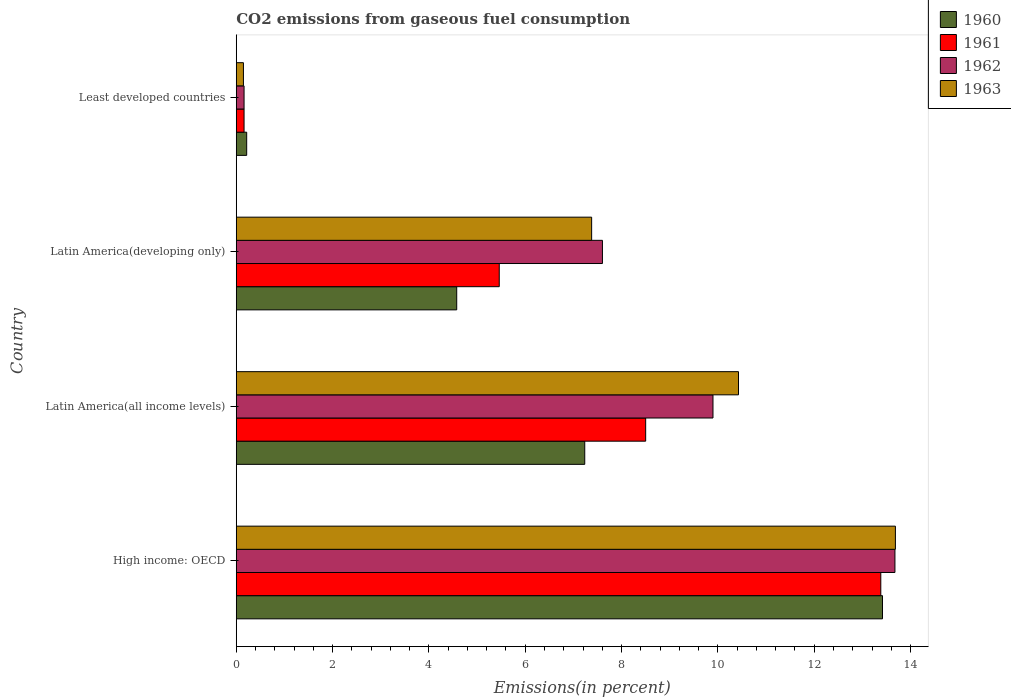Are the number of bars on each tick of the Y-axis equal?
Make the answer very short. Yes. How many bars are there on the 4th tick from the top?
Offer a very short reply. 4. What is the label of the 2nd group of bars from the top?
Your answer should be compact. Latin America(developing only). In how many cases, is the number of bars for a given country not equal to the number of legend labels?
Provide a succinct answer. 0. What is the total CO2 emitted in 1963 in Latin America(developing only)?
Your answer should be very brief. 7.38. Across all countries, what is the maximum total CO2 emitted in 1961?
Your response must be concise. 13.38. Across all countries, what is the minimum total CO2 emitted in 1961?
Keep it short and to the point. 0.16. In which country was the total CO2 emitted in 1960 maximum?
Offer a very short reply. High income: OECD. In which country was the total CO2 emitted in 1962 minimum?
Keep it short and to the point. Least developed countries. What is the total total CO2 emitted in 1961 in the graph?
Your response must be concise. 27.51. What is the difference between the total CO2 emitted in 1962 in High income: OECD and that in Least developed countries?
Ensure brevity in your answer.  13.51. What is the difference between the total CO2 emitted in 1963 in Latin America(developing only) and the total CO2 emitted in 1960 in Least developed countries?
Your answer should be compact. 7.16. What is the average total CO2 emitted in 1963 per country?
Give a very brief answer. 7.91. What is the difference between the total CO2 emitted in 1960 and total CO2 emitted in 1962 in High income: OECD?
Your answer should be very brief. -0.26. What is the ratio of the total CO2 emitted in 1961 in Latin America(all income levels) to that in Least developed countries?
Provide a short and direct response. 52.47. Is the total CO2 emitted in 1961 in High income: OECD less than that in Latin America(all income levels)?
Offer a very short reply. No. Is the difference between the total CO2 emitted in 1960 in Latin America(all income levels) and Latin America(developing only) greater than the difference between the total CO2 emitted in 1962 in Latin America(all income levels) and Latin America(developing only)?
Give a very brief answer. Yes. What is the difference between the highest and the second highest total CO2 emitted in 1962?
Provide a short and direct response. 3.78. What is the difference between the highest and the lowest total CO2 emitted in 1961?
Keep it short and to the point. 13.22. Is it the case that in every country, the sum of the total CO2 emitted in 1962 and total CO2 emitted in 1960 is greater than the total CO2 emitted in 1961?
Your answer should be very brief. Yes. How many countries are there in the graph?
Give a very brief answer. 4. What is the difference between two consecutive major ticks on the X-axis?
Your answer should be compact. 2. Does the graph contain any zero values?
Ensure brevity in your answer.  No. Does the graph contain grids?
Your response must be concise. No. What is the title of the graph?
Make the answer very short. CO2 emissions from gaseous fuel consumption. What is the label or title of the X-axis?
Keep it short and to the point. Emissions(in percent). What is the Emissions(in percent) of 1960 in High income: OECD?
Offer a very short reply. 13.42. What is the Emissions(in percent) in 1961 in High income: OECD?
Offer a terse response. 13.38. What is the Emissions(in percent) in 1962 in High income: OECD?
Your answer should be very brief. 13.68. What is the Emissions(in percent) in 1963 in High income: OECD?
Ensure brevity in your answer.  13.69. What is the Emissions(in percent) of 1960 in Latin America(all income levels)?
Offer a terse response. 7.24. What is the Emissions(in percent) of 1961 in Latin America(all income levels)?
Your answer should be compact. 8.5. What is the Emissions(in percent) in 1962 in Latin America(all income levels)?
Your answer should be compact. 9.9. What is the Emissions(in percent) of 1963 in Latin America(all income levels)?
Offer a terse response. 10.43. What is the Emissions(in percent) of 1960 in Latin America(developing only)?
Offer a very short reply. 4.58. What is the Emissions(in percent) in 1961 in Latin America(developing only)?
Give a very brief answer. 5.46. What is the Emissions(in percent) in 1962 in Latin America(developing only)?
Provide a succinct answer. 7.6. What is the Emissions(in percent) of 1963 in Latin America(developing only)?
Give a very brief answer. 7.38. What is the Emissions(in percent) in 1960 in Least developed countries?
Your response must be concise. 0.22. What is the Emissions(in percent) in 1961 in Least developed countries?
Offer a terse response. 0.16. What is the Emissions(in percent) in 1962 in Least developed countries?
Provide a short and direct response. 0.16. What is the Emissions(in percent) in 1963 in Least developed countries?
Provide a short and direct response. 0.15. Across all countries, what is the maximum Emissions(in percent) in 1960?
Provide a succinct answer. 13.42. Across all countries, what is the maximum Emissions(in percent) of 1961?
Offer a very short reply. 13.38. Across all countries, what is the maximum Emissions(in percent) in 1962?
Offer a very short reply. 13.68. Across all countries, what is the maximum Emissions(in percent) in 1963?
Your answer should be compact. 13.69. Across all countries, what is the minimum Emissions(in percent) of 1960?
Provide a short and direct response. 0.22. Across all countries, what is the minimum Emissions(in percent) of 1961?
Your response must be concise. 0.16. Across all countries, what is the minimum Emissions(in percent) in 1962?
Ensure brevity in your answer.  0.16. Across all countries, what is the minimum Emissions(in percent) of 1963?
Ensure brevity in your answer.  0.15. What is the total Emissions(in percent) in 1960 in the graph?
Keep it short and to the point. 25.45. What is the total Emissions(in percent) in 1961 in the graph?
Ensure brevity in your answer.  27.51. What is the total Emissions(in percent) of 1962 in the graph?
Offer a terse response. 31.34. What is the total Emissions(in percent) in 1963 in the graph?
Provide a succinct answer. 31.64. What is the difference between the Emissions(in percent) in 1960 in High income: OECD and that in Latin America(all income levels)?
Your answer should be very brief. 6.18. What is the difference between the Emissions(in percent) in 1961 in High income: OECD and that in Latin America(all income levels)?
Provide a succinct answer. 4.88. What is the difference between the Emissions(in percent) in 1962 in High income: OECD and that in Latin America(all income levels)?
Your answer should be very brief. 3.78. What is the difference between the Emissions(in percent) in 1963 in High income: OECD and that in Latin America(all income levels)?
Make the answer very short. 3.26. What is the difference between the Emissions(in percent) in 1960 in High income: OECD and that in Latin America(developing only)?
Ensure brevity in your answer.  8.84. What is the difference between the Emissions(in percent) in 1961 in High income: OECD and that in Latin America(developing only)?
Ensure brevity in your answer.  7.92. What is the difference between the Emissions(in percent) of 1962 in High income: OECD and that in Latin America(developing only)?
Make the answer very short. 6.07. What is the difference between the Emissions(in percent) in 1963 in High income: OECD and that in Latin America(developing only)?
Your answer should be compact. 6.31. What is the difference between the Emissions(in percent) of 1960 in High income: OECD and that in Least developed countries?
Offer a terse response. 13.2. What is the difference between the Emissions(in percent) in 1961 in High income: OECD and that in Least developed countries?
Your response must be concise. 13.22. What is the difference between the Emissions(in percent) in 1962 in High income: OECD and that in Least developed countries?
Your response must be concise. 13.51. What is the difference between the Emissions(in percent) in 1963 in High income: OECD and that in Least developed countries?
Your response must be concise. 13.54. What is the difference between the Emissions(in percent) of 1960 in Latin America(all income levels) and that in Latin America(developing only)?
Give a very brief answer. 2.66. What is the difference between the Emissions(in percent) in 1961 in Latin America(all income levels) and that in Latin America(developing only)?
Your answer should be very brief. 3.04. What is the difference between the Emissions(in percent) of 1962 in Latin America(all income levels) and that in Latin America(developing only)?
Your answer should be very brief. 2.3. What is the difference between the Emissions(in percent) of 1963 in Latin America(all income levels) and that in Latin America(developing only)?
Provide a short and direct response. 3.05. What is the difference between the Emissions(in percent) of 1960 in Latin America(all income levels) and that in Least developed countries?
Keep it short and to the point. 7.02. What is the difference between the Emissions(in percent) in 1961 in Latin America(all income levels) and that in Least developed countries?
Ensure brevity in your answer.  8.34. What is the difference between the Emissions(in percent) in 1962 in Latin America(all income levels) and that in Least developed countries?
Your answer should be compact. 9.74. What is the difference between the Emissions(in percent) of 1963 in Latin America(all income levels) and that in Least developed countries?
Provide a succinct answer. 10.28. What is the difference between the Emissions(in percent) of 1960 in Latin America(developing only) and that in Least developed countries?
Make the answer very short. 4.36. What is the difference between the Emissions(in percent) of 1961 in Latin America(developing only) and that in Least developed countries?
Offer a terse response. 5.3. What is the difference between the Emissions(in percent) of 1962 in Latin America(developing only) and that in Least developed countries?
Your response must be concise. 7.44. What is the difference between the Emissions(in percent) in 1963 in Latin America(developing only) and that in Least developed countries?
Make the answer very short. 7.23. What is the difference between the Emissions(in percent) in 1960 in High income: OECD and the Emissions(in percent) in 1961 in Latin America(all income levels)?
Ensure brevity in your answer.  4.92. What is the difference between the Emissions(in percent) in 1960 in High income: OECD and the Emissions(in percent) in 1962 in Latin America(all income levels)?
Your answer should be compact. 3.52. What is the difference between the Emissions(in percent) in 1960 in High income: OECD and the Emissions(in percent) in 1963 in Latin America(all income levels)?
Offer a very short reply. 2.99. What is the difference between the Emissions(in percent) in 1961 in High income: OECD and the Emissions(in percent) in 1962 in Latin America(all income levels)?
Give a very brief answer. 3.48. What is the difference between the Emissions(in percent) of 1961 in High income: OECD and the Emissions(in percent) of 1963 in Latin America(all income levels)?
Your answer should be compact. 2.95. What is the difference between the Emissions(in percent) of 1962 in High income: OECD and the Emissions(in percent) of 1963 in Latin America(all income levels)?
Keep it short and to the point. 3.25. What is the difference between the Emissions(in percent) in 1960 in High income: OECD and the Emissions(in percent) in 1961 in Latin America(developing only)?
Give a very brief answer. 7.96. What is the difference between the Emissions(in percent) in 1960 in High income: OECD and the Emissions(in percent) in 1962 in Latin America(developing only)?
Provide a succinct answer. 5.82. What is the difference between the Emissions(in percent) in 1960 in High income: OECD and the Emissions(in percent) in 1963 in Latin America(developing only)?
Offer a terse response. 6.04. What is the difference between the Emissions(in percent) of 1961 in High income: OECD and the Emissions(in percent) of 1962 in Latin America(developing only)?
Ensure brevity in your answer.  5.78. What is the difference between the Emissions(in percent) of 1961 in High income: OECD and the Emissions(in percent) of 1963 in Latin America(developing only)?
Offer a terse response. 6. What is the difference between the Emissions(in percent) in 1962 in High income: OECD and the Emissions(in percent) in 1963 in Latin America(developing only)?
Your answer should be compact. 6.3. What is the difference between the Emissions(in percent) in 1960 in High income: OECD and the Emissions(in percent) in 1961 in Least developed countries?
Ensure brevity in your answer.  13.26. What is the difference between the Emissions(in percent) in 1960 in High income: OECD and the Emissions(in percent) in 1962 in Least developed countries?
Keep it short and to the point. 13.26. What is the difference between the Emissions(in percent) in 1960 in High income: OECD and the Emissions(in percent) in 1963 in Least developed countries?
Ensure brevity in your answer.  13.27. What is the difference between the Emissions(in percent) in 1961 in High income: OECD and the Emissions(in percent) in 1962 in Least developed countries?
Give a very brief answer. 13.22. What is the difference between the Emissions(in percent) of 1961 in High income: OECD and the Emissions(in percent) of 1963 in Least developed countries?
Your answer should be very brief. 13.23. What is the difference between the Emissions(in percent) in 1962 in High income: OECD and the Emissions(in percent) in 1963 in Least developed countries?
Offer a terse response. 13.53. What is the difference between the Emissions(in percent) in 1960 in Latin America(all income levels) and the Emissions(in percent) in 1961 in Latin America(developing only)?
Provide a short and direct response. 1.78. What is the difference between the Emissions(in percent) in 1960 in Latin America(all income levels) and the Emissions(in percent) in 1962 in Latin America(developing only)?
Provide a short and direct response. -0.37. What is the difference between the Emissions(in percent) of 1960 in Latin America(all income levels) and the Emissions(in percent) of 1963 in Latin America(developing only)?
Your answer should be compact. -0.14. What is the difference between the Emissions(in percent) of 1961 in Latin America(all income levels) and the Emissions(in percent) of 1962 in Latin America(developing only)?
Your answer should be very brief. 0.9. What is the difference between the Emissions(in percent) in 1961 in Latin America(all income levels) and the Emissions(in percent) in 1963 in Latin America(developing only)?
Make the answer very short. 1.12. What is the difference between the Emissions(in percent) in 1962 in Latin America(all income levels) and the Emissions(in percent) in 1963 in Latin America(developing only)?
Provide a succinct answer. 2.52. What is the difference between the Emissions(in percent) of 1960 in Latin America(all income levels) and the Emissions(in percent) of 1961 in Least developed countries?
Make the answer very short. 7.07. What is the difference between the Emissions(in percent) of 1960 in Latin America(all income levels) and the Emissions(in percent) of 1962 in Least developed countries?
Make the answer very short. 7.07. What is the difference between the Emissions(in percent) of 1960 in Latin America(all income levels) and the Emissions(in percent) of 1963 in Least developed countries?
Your answer should be compact. 7.09. What is the difference between the Emissions(in percent) of 1961 in Latin America(all income levels) and the Emissions(in percent) of 1962 in Least developed countries?
Make the answer very short. 8.34. What is the difference between the Emissions(in percent) in 1961 in Latin America(all income levels) and the Emissions(in percent) in 1963 in Least developed countries?
Your answer should be very brief. 8.35. What is the difference between the Emissions(in percent) in 1962 in Latin America(all income levels) and the Emissions(in percent) in 1963 in Least developed countries?
Your answer should be compact. 9.75. What is the difference between the Emissions(in percent) of 1960 in Latin America(developing only) and the Emissions(in percent) of 1961 in Least developed countries?
Your answer should be very brief. 4.42. What is the difference between the Emissions(in percent) in 1960 in Latin America(developing only) and the Emissions(in percent) in 1962 in Least developed countries?
Offer a very short reply. 4.42. What is the difference between the Emissions(in percent) in 1960 in Latin America(developing only) and the Emissions(in percent) in 1963 in Least developed countries?
Provide a succinct answer. 4.43. What is the difference between the Emissions(in percent) of 1961 in Latin America(developing only) and the Emissions(in percent) of 1962 in Least developed countries?
Ensure brevity in your answer.  5.3. What is the difference between the Emissions(in percent) of 1961 in Latin America(developing only) and the Emissions(in percent) of 1963 in Least developed countries?
Make the answer very short. 5.31. What is the difference between the Emissions(in percent) in 1962 in Latin America(developing only) and the Emissions(in percent) in 1963 in Least developed countries?
Provide a short and direct response. 7.45. What is the average Emissions(in percent) in 1960 per country?
Offer a very short reply. 6.36. What is the average Emissions(in percent) in 1961 per country?
Provide a short and direct response. 6.88. What is the average Emissions(in percent) in 1962 per country?
Your response must be concise. 7.83. What is the average Emissions(in percent) of 1963 per country?
Keep it short and to the point. 7.91. What is the difference between the Emissions(in percent) of 1960 and Emissions(in percent) of 1961 in High income: OECD?
Keep it short and to the point. 0.04. What is the difference between the Emissions(in percent) in 1960 and Emissions(in percent) in 1962 in High income: OECD?
Provide a short and direct response. -0.26. What is the difference between the Emissions(in percent) of 1960 and Emissions(in percent) of 1963 in High income: OECD?
Make the answer very short. -0.27. What is the difference between the Emissions(in percent) of 1961 and Emissions(in percent) of 1962 in High income: OECD?
Your answer should be compact. -0.29. What is the difference between the Emissions(in percent) in 1961 and Emissions(in percent) in 1963 in High income: OECD?
Your answer should be compact. -0.3. What is the difference between the Emissions(in percent) in 1962 and Emissions(in percent) in 1963 in High income: OECD?
Your answer should be very brief. -0.01. What is the difference between the Emissions(in percent) in 1960 and Emissions(in percent) in 1961 in Latin America(all income levels)?
Your answer should be compact. -1.26. What is the difference between the Emissions(in percent) of 1960 and Emissions(in percent) of 1962 in Latin America(all income levels)?
Your response must be concise. -2.66. What is the difference between the Emissions(in percent) in 1960 and Emissions(in percent) in 1963 in Latin America(all income levels)?
Your answer should be compact. -3.19. What is the difference between the Emissions(in percent) in 1961 and Emissions(in percent) in 1962 in Latin America(all income levels)?
Your answer should be compact. -1.4. What is the difference between the Emissions(in percent) of 1961 and Emissions(in percent) of 1963 in Latin America(all income levels)?
Your response must be concise. -1.93. What is the difference between the Emissions(in percent) in 1962 and Emissions(in percent) in 1963 in Latin America(all income levels)?
Your answer should be very brief. -0.53. What is the difference between the Emissions(in percent) of 1960 and Emissions(in percent) of 1961 in Latin America(developing only)?
Offer a very short reply. -0.88. What is the difference between the Emissions(in percent) in 1960 and Emissions(in percent) in 1962 in Latin America(developing only)?
Your response must be concise. -3.03. What is the difference between the Emissions(in percent) in 1960 and Emissions(in percent) in 1963 in Latin America(developing only)?
Provide a short and direct response. -2.8. What is the difference between the Emissions(in percent) in 1961 and Emissions(in percent) in 1962 in Latin America(developing only)?
Your answer should be compact. -2.14. What is the difference between the Emissions(in percent) of 1961 and Emissions(in percent) of 1963 in Latin America(developing only)?
Offer a very short reply. -1.92. What is the difference between the Emissions(in percent) of 1962 and Emissions(in percent) of 1963 in Latin America(developing only)?
Make the answer very short. 0.22. What is the difference between the Emissions(in percent) of 1960 and Emissions(in percent) of 1961 in Least developed countries?
Offer a very short reply. 0.05. What is the difference between the Emissions(in percent) of 1960 and Emissions(in percent) of 1962 in Least developed countries?
Ensure brevity in your answer.  0.05. What is the difference between the Emissions(in percent) in 1960 and Emissions(in percent) in 1963 in Least developed countries?
Make the answer very short. 0.07. What is the difference between the Emissions(in percent) in 1961 and Emissions(in percent) in 1962 in Least developed countries?
Offer a very short reply. -0. What is the difference between the Emissions(in percent) in 1961 and Emissions(in percent) in 1963 in Least developed countries?
Provide a succinct answer. 0.01. What is the difference between the Emissions(in percent) of 1962 and Emissions(in percent) of 1963 in Least developed countries?
Give a very brief answer. 0.01. What is the ratio of the Emissions(in percent) in 1960 in High income: OECD to that in Latin America(all income levels)?
Keep it short and to the point. 1.85. What is the ratio of the Emissions(in percent) in 1961 in High income: OECD to that in Latin America(all income levels)?
Make the answer very short. 1.57. What is the ratio of the Emissions(in percent) of 1962 in High income: OECD to that in Latin America(all income levels)?
Provide a succinct answer. 1.38. What is the ratio of the Emissions(in percent) of 1963 in High income: OECD to that in Latin America(all income levels)?
Ensure brevity in your answer.  1.31. What is the ratio of the Emissions(in percent) of 1960 in High income: OECD to that in Latin America(developing only)?
Make the answer very short. 2.93. What is the ratio of the Emissions(in percent) of 1961 in High income: OECD to that in Latin America(developing only)?
Give a very brief answer. 2.45. What is the ratio of the Emissions(in percent) of 1962 in High income: OECD to that in Latin America(developing only)?
Make the answer very short. 1.8. What is the ratio of the Emissions(in percent) in 1963 in High income: OECD to that in Latin America(developing only)?
Ensure brevity in your answer.  1.85. What is the ratio of the Emissions(in percent) in 1960 in High income: OECD to that in Least developed countries?
Give a very brief answer. 61.91. What is the ratio of the Emissions(in percent) in 1961 in High income: OECD to that in Least developed countries?
Your response must be concise. 82.61. What is the ratio of the Emissions(in percent) in 1962 in High income: OECD to that in Least developed countries?
Your answer should be compact. 84.34. What is the ratio of the Emissions(in percent) of 1963 in High income: OECD to that in Least developed countries?
Ensure brevity in your answer.  91.71. What is the ratio of the Emissions(in percent) of 1960 in Latin America(all income levels) to that in Latin America(developing only)?
Your response must be concise. 1.58. What is the ratio of the Emissions(in percent) of 1961 in Latin America(all income levels) to that in Latin America(developing only)?
Give a very brief answer. 1.56. What is the ratio of the Emissions(in percent) in 1962 in Latin America(all income levels) to that in Latin America(developing only)?
Offer a very short reply. 1.3. What is the ratio of the Emissions(in percent) of 1963 in Latin America(all income levels) to that in Latin America(developing only)?
Ensure brevity in your answer.  1.41. What is the ratio of the Emissions(in percent) in 1960 in Latin America(all income levels) to that in Least developed countries?
Your response must be concise. 33.38. What is the ratio of the Emissions(in percent) in 1961 in Latin America(all income levels) to that in Least developed countries?
Your response must be concise. 52.47. What is the ratio of the Emissions(in percent) in 1962 in Latin America(all income levels) to that in Least developed countries?
Keep it short and to the point. 61.04. What is the ratio of the Emissions(in percent) of 1963 in Latin America(all income levels) to that in Least developed countries?
Give a very brief answer. 69.88. What is the ratio of the Emissions(in percent) in 1960 in Latin America(developing only) to that in Least developed countries?
Give a very brief answer. 21.12. What is the ratio of the Emissions(in percent) of 1961 in Latin America(developing only) to that in Least developed countries?
Keep it short and to the point. 33.71. What is the ratio of the Emissions(in percent) of 1962 in Latin America(developing only) to that in Least developed countries?
Offer a very short reply. 46.89. What is the ratio of the Emissions(in percent) in 1963 in Latin America(developing only) to that in Least developed countries?
Your answer should be very brief. 49.45. What is the difference between the highest and the second highest Emissions(in percent) in 1960?
Your response must be concise. 6.18. What is the difference between the highest and the second highest Emissions(in percent) in 1961?
Your answer should be compact. 4.88. What is the difference between the highest and the second highest Emissions(in percent) of 1962?
Provide a succinct answer. 3.78. What is the difference between the highest and the second highest Emissions(in percent) of 1963?
Provide a succinct answer. 3.26. What is the difference between the highest and the lowest Emissions(in percent) in 1960?
Offer a terse response. 13.2. What is the difference between the highest and the lowest Emissions(in percent) in 1961?
Provide a succinct answer. 13.22. What is the difference between the highest and the lowest Emissions(in percent) in 1962?
Keep it short and to the point. 13.51. What is the difference between the highest and the lowest Emissions(in percent) in 1963?
Offer a terse response. 13.54. 